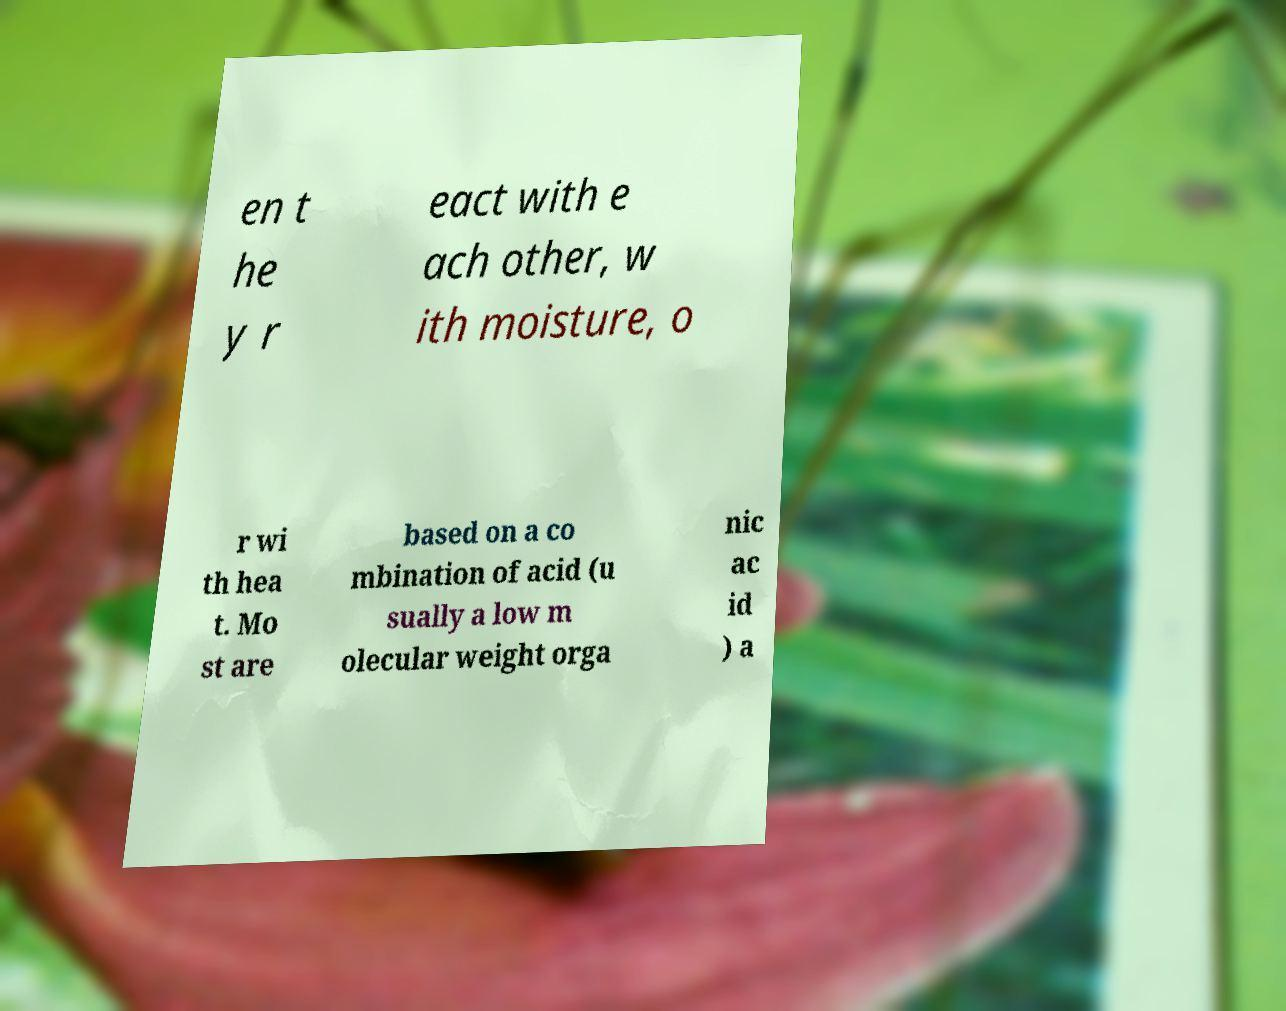Please read and relay the text visible in this image. What does it say? en t he y r eact with e ach other, w ith moisture, o r wi th hea t. Mo st are based on a co mbination of acid (u sually a low m olecular weight orga nic ac id ) a 